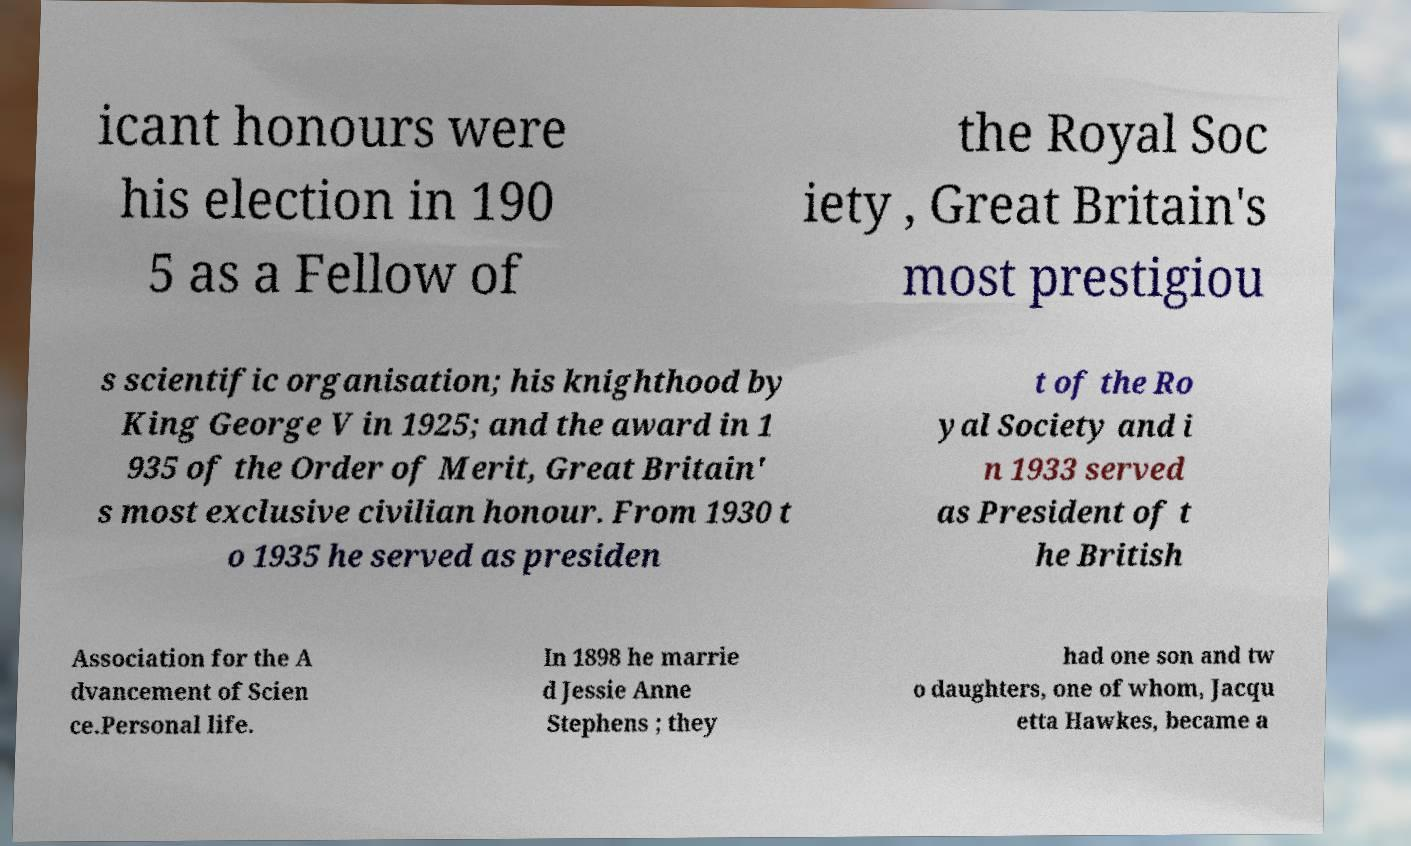For documentation purposes, I need the text within this image transcribed. Could you provide that? icant honours were his election in 190 5 as a Fellow of the Royal Soc iety , Great Britain's most prestigiou s scientific organisation; his knighthood by King George V in 1925; and the award in 1 935 of the Order of Merit, Great Britain' s most exclusive civilian honour. From 1930 t o 1935 he served as presiden t of the Ro yal Society and i n 1933 served as President of t he British Association for the A dvancement of Scien ce.Personal life. In 1898 he marrie d Jessie Anne Stephens ; they had one son and tw o daughters, one of whom, Jacqu etta Hawkes, became a 